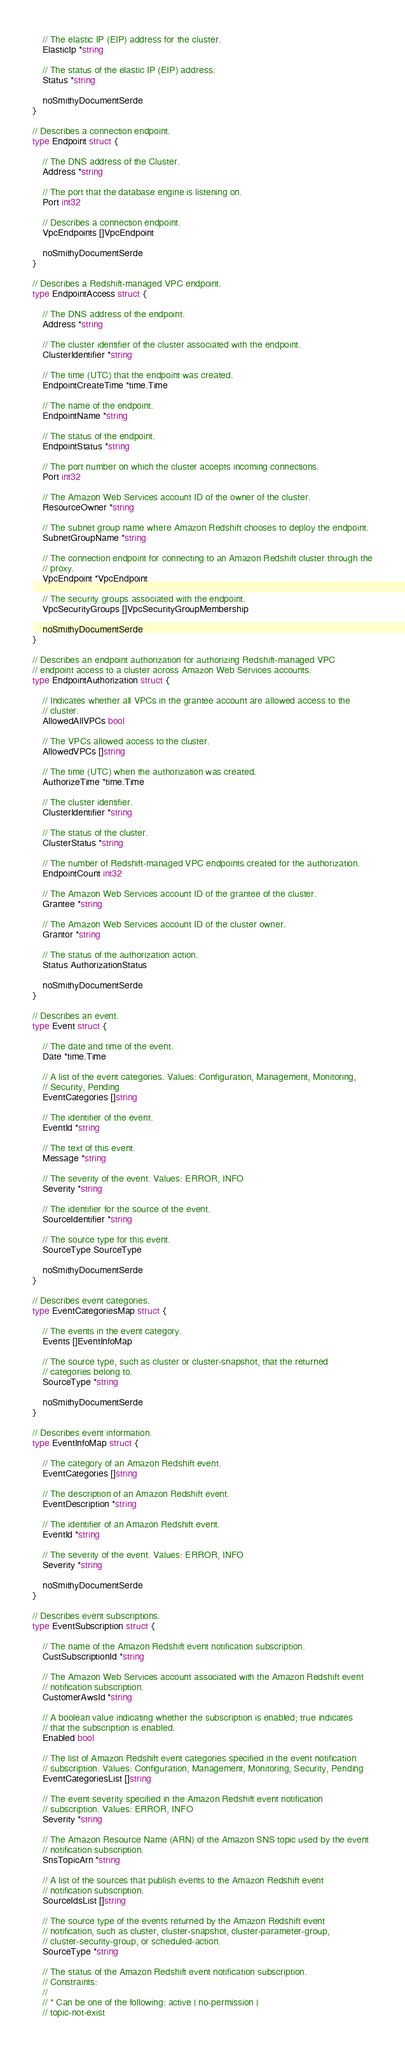<code> <loc_0><loc_0><loc_500><loc_500><_Go_>
	// The elastic IP (EIP) address for the cluster.
	ElasticIp *string

	// The status of the elastic IP (EIP) address.
	Status *string

	noSmithyDocumentSerde
}

// Describes a connection endpoint.
type Endpoint struct {

	// The DNS address of the Cluster.
	Address *string

	// The port that the database engine is listening on.
	Port int32

	// Describes a connection endpoint.
	VpcEndpoints []VpcEndpoint

	noSmithyDocumentSerde
}

// Describes a Redshift-managed VPC endpoint.
type EndpointAccess struct {

	// The DNS address of the endpoint.
	Address *string

	// The cluster identifier of the cluster associated with the endpoint.
	ClusterIdentifier *string

	// The time (UTC) that the endpoint was created.
	EndpointCreateTime *time.Time

	// The name of the endpoint.
	EndpointName *string

	// The status of the endpoint.
	EndpointStatus *string

	// The port number on which the cluster accepts incoming connections.
	Port int32

	// The Amazon Web Services account ID of the owner of the cluster.
	ResourceOwner *string

	// The subnet group name where Amazon Redshift chooses to deploy the endpoint.
	SubnetGroupName *string

	// The connection endpoint for connecting to an Amazon Redshift cluster through the
	// proxy.
	VpcEndpoint *VpcEndpoint

	// The security groups associated with the endpoint.
	VpcSecurityGroups []VpcSecurityGroupMembership

	noSmithyDocumentSerde
}

// Describes an endpoint authorization for authorizing Redshift-managed VPC
// endpoint access to a cluster across Amazon Web Services accounts.
type EndpointAuthorization struct {

	// Indicates whether all VPCs in the grantee account are allowed access to the
	// cluster.
	AllowedAllVPCs bool

	// The VPCs allowed access to the cluster.
	AllowedVPCs []string

	// The time (UTC) when the authorization was created.
	AuthorizeTime *time.Time

	// The cluster identifier.
	ClusterIdentifier *string

	// The status of the cluster.
	ClusterStatus *string

	// The number of Redshift-managed VPC endpoints created for the authorization.
	EndpointCount int32

	// The Amazon Web Services account ID of the grantee of the cluster.
	Grantee *string

	// The Amazon Web Services account ID of the cluster owner.
	Grantor *string

	// The status of the authorization action.
	Status AuthorizationStatus

	noSmithyDocumentSerde
}

// Describes an event.
type Event struct {

	// The date and time of the event.
	Date *time.Time

	// A list of the event categories. Values: Configuration, Management, Monitoring,
	// Security, Pending
	EventCategories []string

	// The identifier of the event.
	EventId *string

	// The text of this event.
	Message *string

	// The severity of the event. Values: ERROR, INFO
	Severity *string

	// The identifier for the source of the event.
	SourceIdentifier *string

	// The source type for this event.
	SourceType SourceType

	noSmithyDocumentSerde
}

// Describes event categories.
type EventCategoriesMap struct {

	// The events in the event category.
	Events []EventInfoMap

	// The source type, such as cluster or cluster-snapshot, that the returned
	// categories belong to.
	SourceType *string

	noSmithyDocumentSerde
}

// Describes event information.
type EventInfoMap struct {

	// The category of an Amazon Redshift event.
	EventCategories []string

	// The description of an Amazon Redshift event.
	EventDescription *string

	// The identifier of an Amazon Redshift event.
	EventId *string

	// The severity of the event. Values: ERROR, INFO
	Severity *string

	noSmithyDocumentSerde
}

// Describes event subscriptions.
type EventSubscription struct {

	// The name of the Amazon Redshift event notification subscription.
	CustSubscriptionId *string

	// The Amazon Web Services account associated with the Amazon Redshift event
	// notification subscription.
	CustomerAwsId *string

	// A boolean value indicating whether the subscription is enabled; true indicates
	// that the subscription is enabled.
	Enabled bool

	// The list of Amazon Redshift event categories specified in the event notification
	// subscription. Values: Configuration, Management, Monitoring, Security, Pending
	EventCategoriesList []string

	// The event severity specified in the Amazon Redshift event notification
	// subscription. Values: ERROR, INFO
	Severity *string

	// The Amazon Resource Name (ARN) of the Amazon SNS topic used by the event
	// notification subscription.
	SnsTopicArn *string

	// A list of the sources that publish events to the Amazon Redshift event
	// notification subscription.
	SourceIdsList []string

	// The source type of the events returned by the Amazon Redshift event
	// notification, such as cluster, cluster-snapshot, cluster-parameter-group,
	// cluster-security-group, or scheduled-action.
	SourceType *string

	// The status of the Amazon Redshift event notification subscription.
	// Constraints:
	//
	// * Can be one of the following: active | no-permission |
	// topic-not-exist</code> 